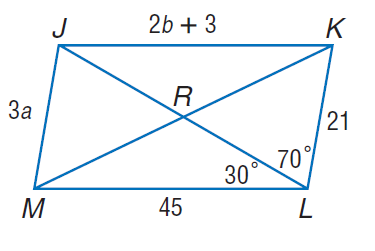Answer the mathemtical geometry problem and directly provide the correct option letter.
Question: Use parallelogram J K L M to find a if J K = 2 b + 3 and J M = 3 a.
Choices: A: 7 B: 14 C: 21 D: 45 A 